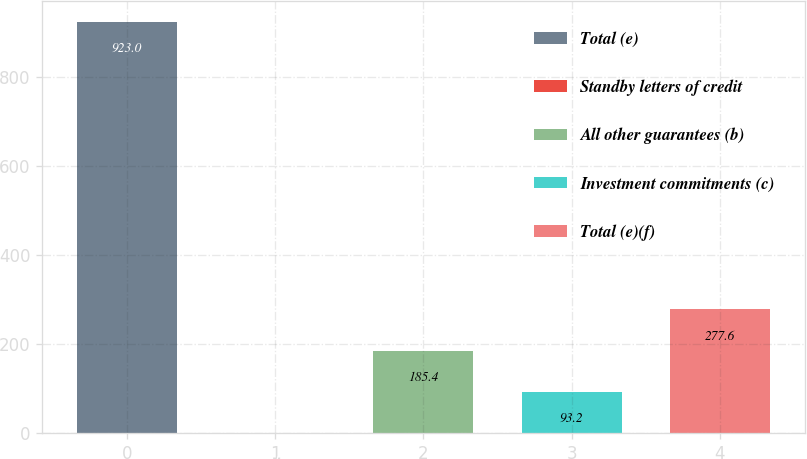Convert chart to OTSL. <chart><loc_0><loc_0><loc_500><loc_500><bar_chart><fcel>Total (e)<fcel>Standby letters of credit<fcel>All other guarantees (b)<fcel>Investment commitments (c)<fcel>Total (e)(f)<nl><fcel>923<fcel>1<fcel>185.4<fcel>93.2<fcel>277.6<nl></chart> 